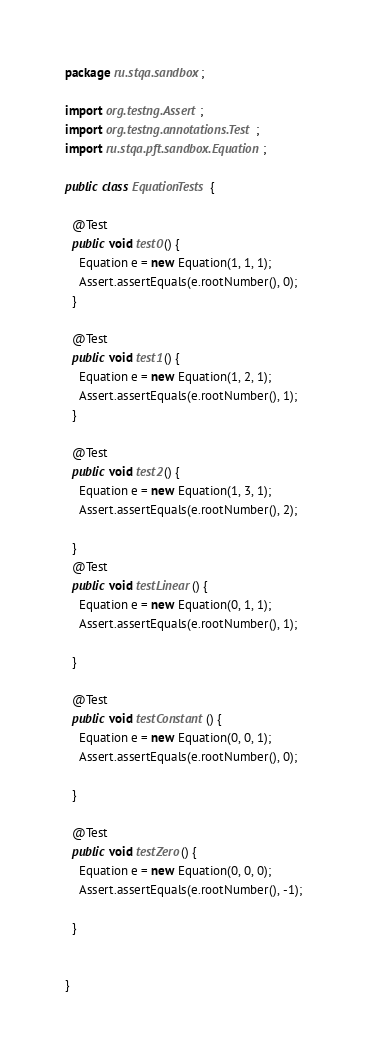Convert code to text. <code><loc_0><loc_0><loc_500><loc_500><_Java_>package ru.stqa.sandbox;

import org.testng.Assert;
import org.testng.annotations.Test;
import ru.stqa.pft.sandbox.Equation;

public class EquationTests {

  @Test
  public void test0() {
    Equation e = new Equation(1, 1, 1);
    Assert.assertEquals(e.rootNumber(), 0);
  }

  @Test
  public void test1() {
    Equation e = new Equation(1, 2, 1);
    Assert.assertEquals(e.rootNumber(), 1);
  }

  @Test
  public void test2() {
    Equation e = new Equation(1, 3, 1);
    Assert.assertEquals(e.rootNumber(), 2);

  }
  @Test
  public void testLinear() {
    Equation e = new Equation(0, 1, 1);
    Assert.assertEquals(e.rootNumber(), 1);

  }

  @Test
  public void testConstant() {
    Equation e = new Equation(0, 0, 1);
    Assert.assertEquals(e.rootNumber(), 0);

  }

  @Test
  public void testZero() {
    Equation e = new Equation(0, 0, 0);
    Assert.assertEquals(e.rootNumber(), -1);

  }


}
</code> 